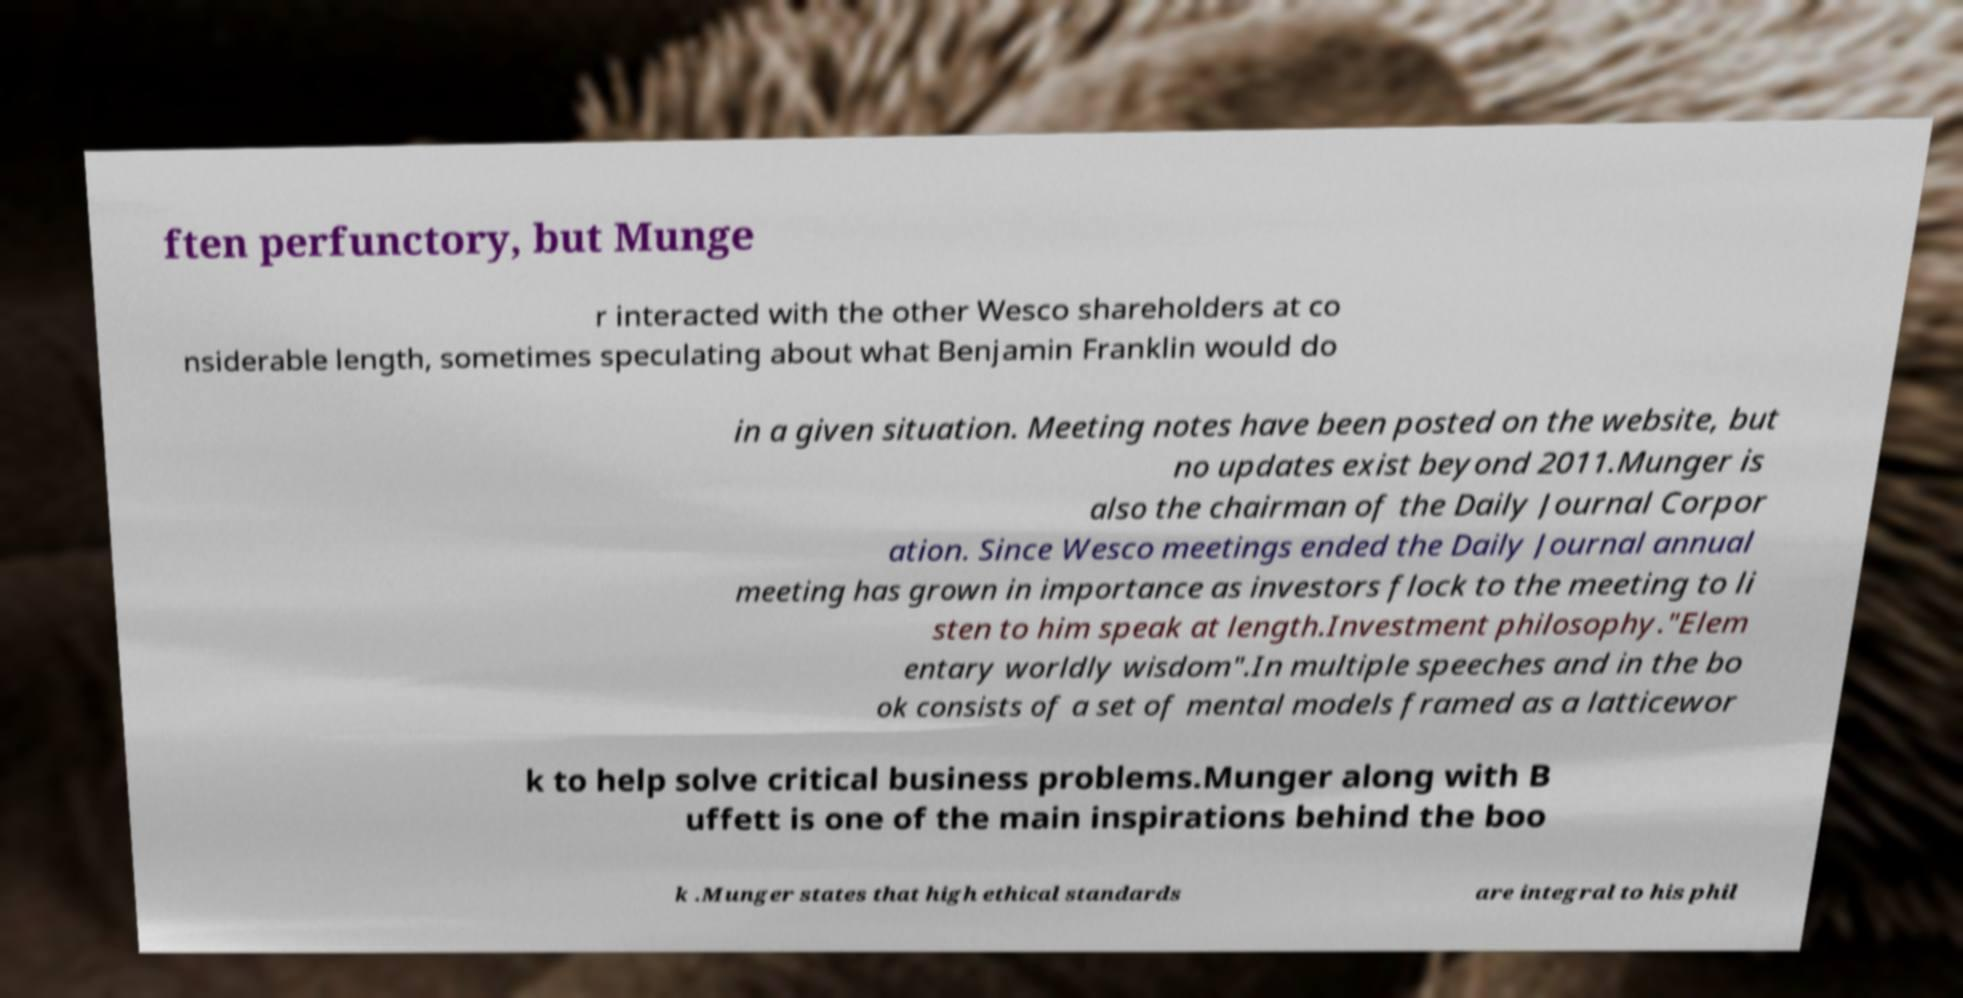Please read and relay the text visible in this image. What does it say? ften perfunctory, but Munge r interacted with the other Wesco shareholders at co nsiderable length, sometimes speculating about what Benjamin Franklin would do in a given situation. Meeting notes have been posted on the website, but no updates exist beyond 2011.Munger is also the chairman of the Daily Journal Corpor ation. Since Wesco meetings ended the Daily Journal annual meeting has grown in importance as investors flock to the meeting to li sten to him speak at length.Investment philosophy."Elem entary worldly wisdom".In multiple speeches and in the bo ok consists of a set of mental models framed as a latticewor k to help solve critical business problems.Munger along with B uffett is one of the main inspirations behind the boo k .Munger states that high ethical standards are integral to his phil 